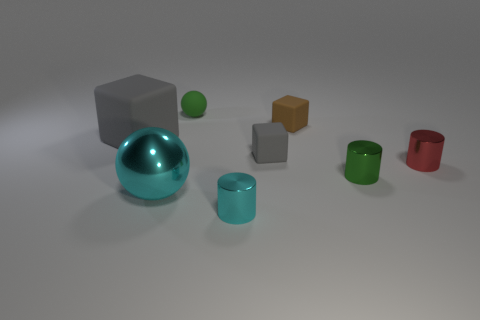Are there fewer cyan cylinders behind the big block than rubber spheres to the left of the large metallic ball?
Provide a short and direct response. No. Is there any other thing that has the same size as the green matte ball?
Your response must be concise. Yes. What size is the red shiny thing?
Offer a very short reply. Small. How many tiny things are gray things or cylinders?
Ensure brevity in your answer.  4. Does the green rubber ball have the same size as the gray matte block that is in front of the large matte thing?
Offer a very short reply. Yes. Is there anything else that is the same shape as the big cyan thing?
Provide a short and direct response. Yes. What number of large objects are there?
Provide a short and direct response. 2. What number of purple things are either rubber objects or metal objects?
Offer a very short reply. 0. Do the cyan ball that is to the left of the small green rubber ball and the tiny gray thing have the same material?
Your answer should be very brief. No. What number of other objects are the same material as the tiny sphere?
Your answer should be compact. 3. 